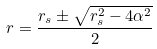<formula> <loc_0><loc_0><loc_500><loc_500>r = \frac { r _ { s } \pm \sqrt { r _ { s } ^ { 2 } - 4 \alpha ^ { 2 } } } { 2 }</formula> 